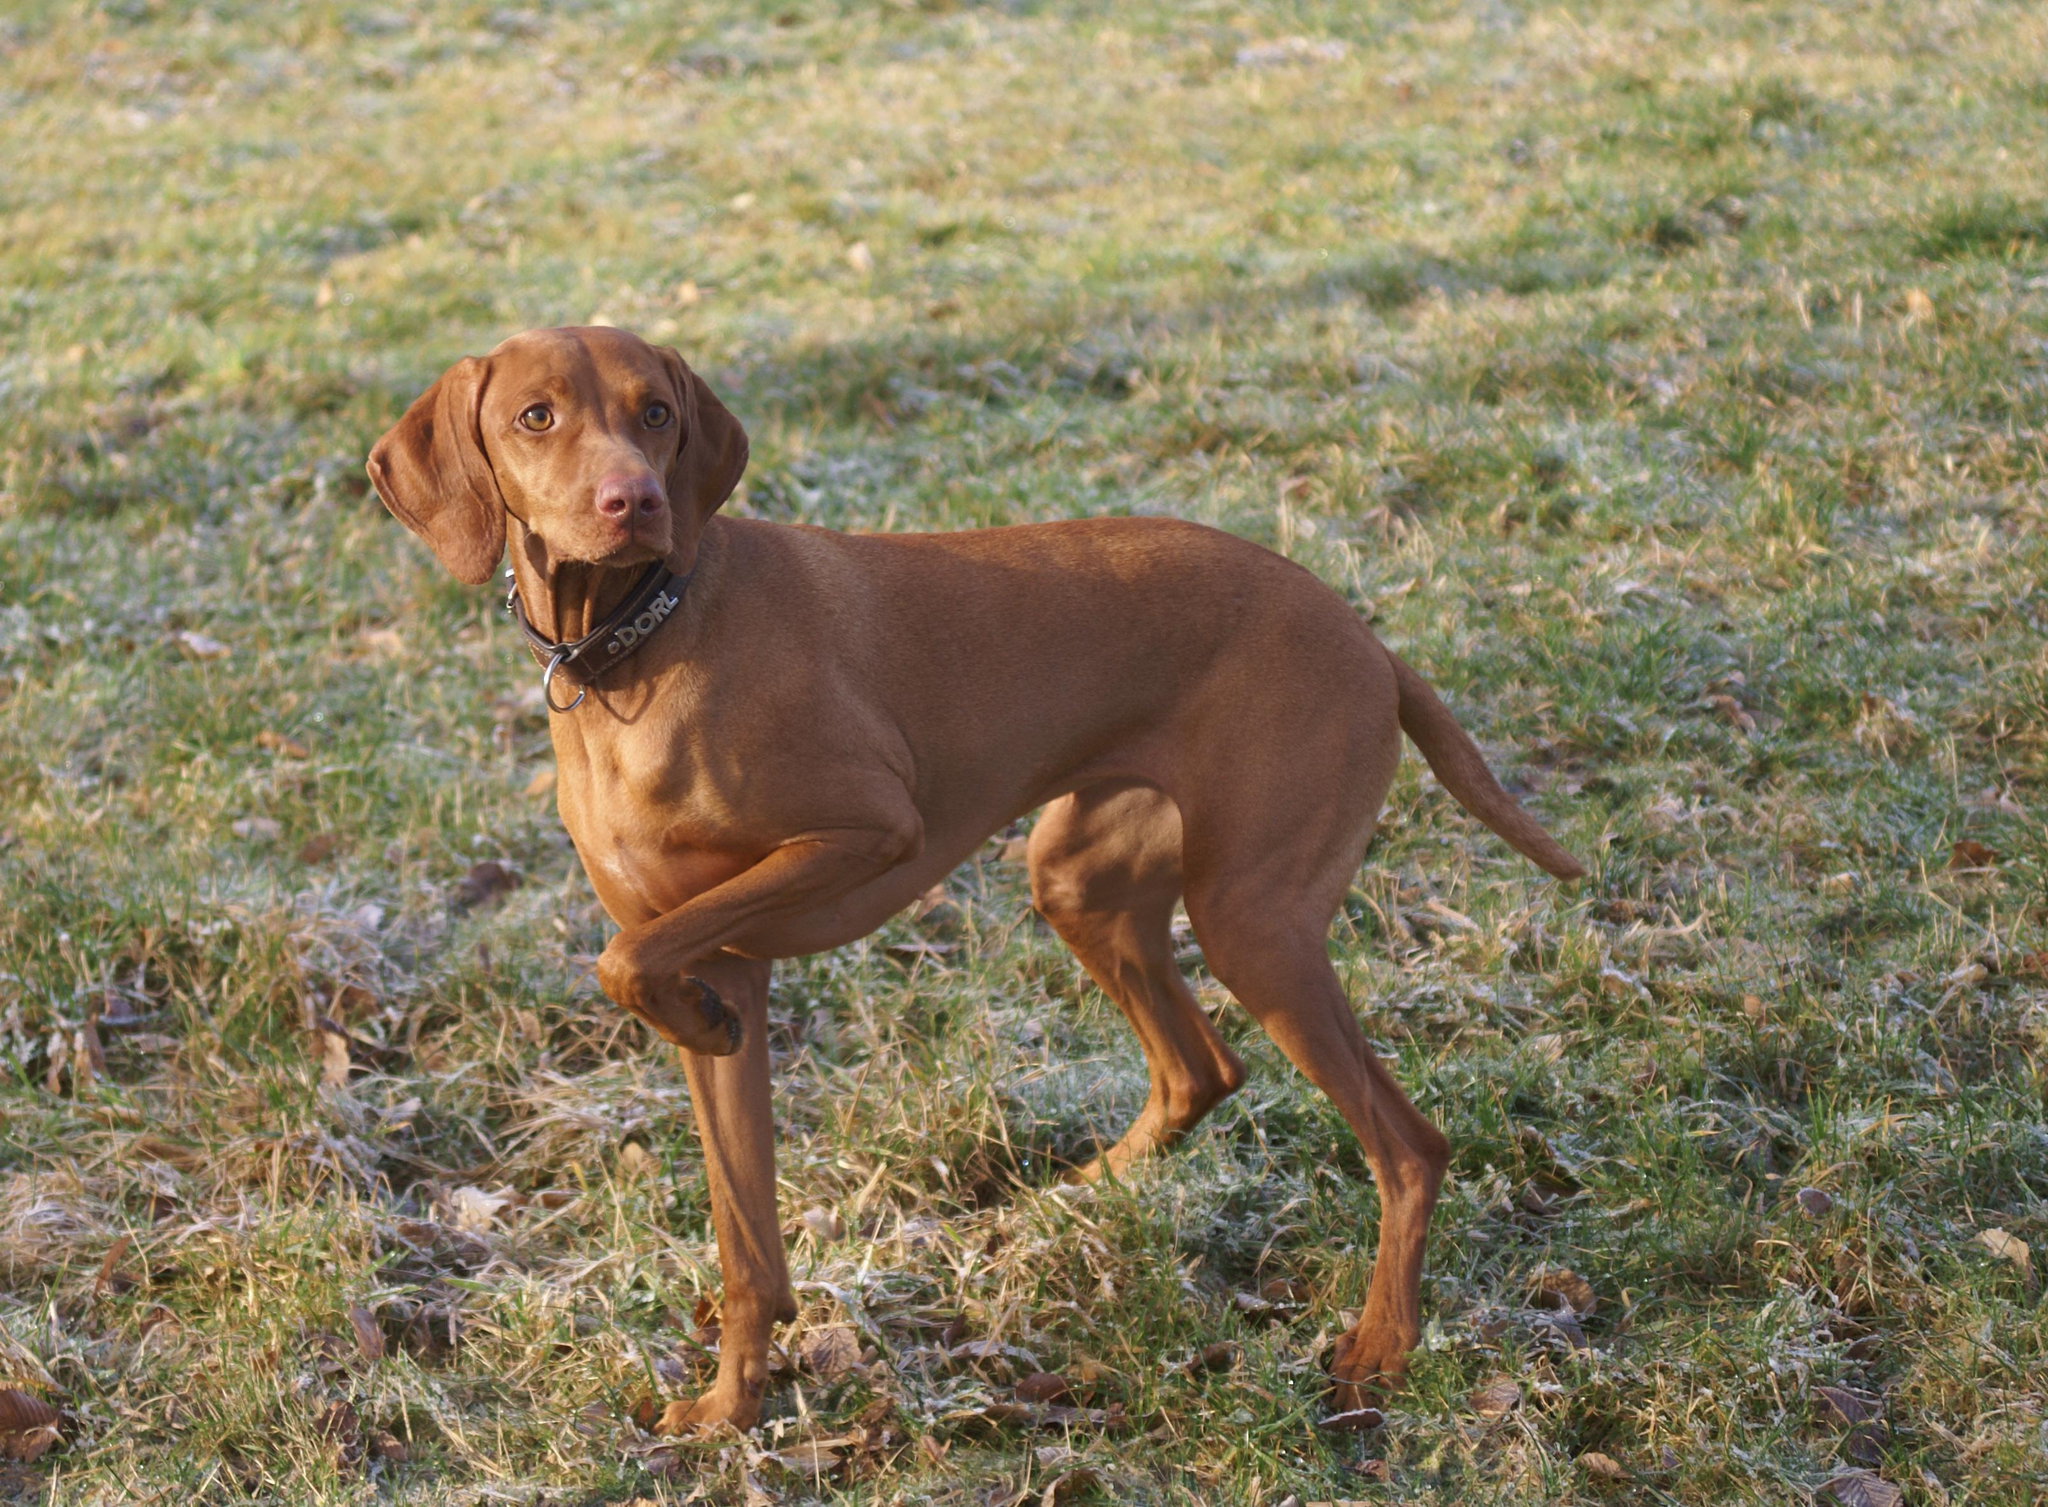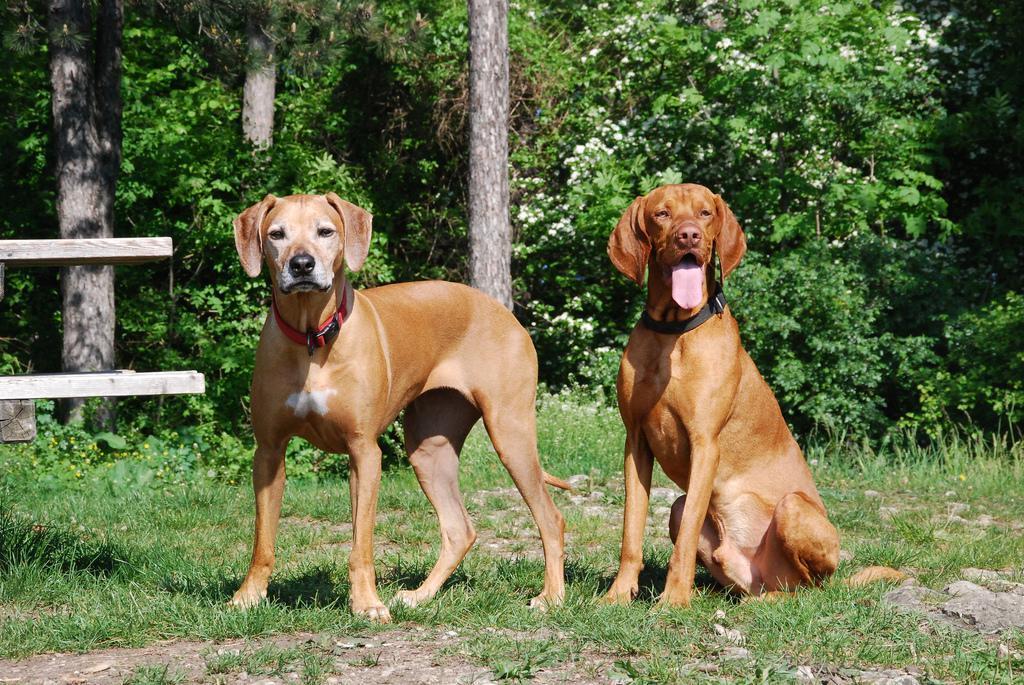The first image is the image on the left, the second image is the image on the right. Considering the images on both sides, is "One image includes a sitting dog wearing a collar, and the other image features a dog with one raised front paw." valid? Answer yes or no. Yes. The first image is the image on the left, the second image is the image on the right. Evaluate the accuracy of this statement regarding the images: "The right image contains exactly two dogs.". Is it true? Answer yes or no. Yes. 